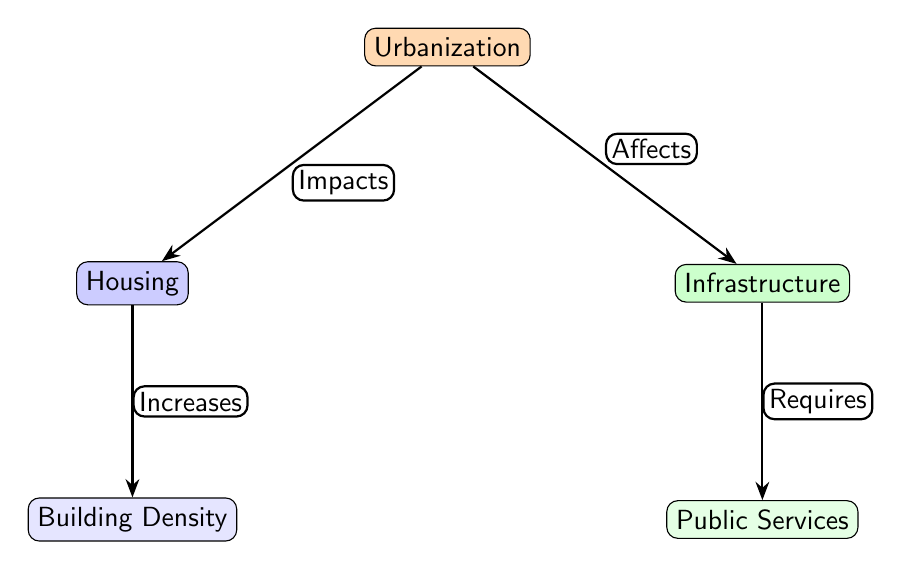What is the central theme of the diagram? The central theme of the diagram is "Urbanization." It is located at the top center of the diagram, indicating that it is the primary concept around which the other elements are organized.
Answer: Urbanization How many nodes are presented in the diagram? The diagram includes five nodes: one for Urbanization, one for Housing, one for Infrastructure, one for Building Density, and one for Public Services. Counting each distinct box gives a total of five nodes.
Answer: Five nodes What effect does urbanization have on housing? Urbanization has a direct impact on housing, as indicated by the arrow labeled "Impacts" connecting Urbanization to Housing. This relationship shows that as urbanization occurs, housing is affected.
Answer: Impacts What relationship is established between housing and building density? The diagram illustrates a direct connection from Housing to Building Density with the label "Increases," indicating that an increase in housing directly correlates to an increase in building density.
Answer: Increases What does infrastructure require according to the diagram? According to the diagram, infrastructure requires public services, as indicated by the arrow labeled "Requires" connecting Infrastructure to Public Services. This shows that as infrastructure develops, it necessitates corresponding public services.
Answer: Requires How does urbanization affect infrastructure according to the diagram? The diagram specifies that urbanization affects infrastructure, as shown by the arrow labeled "Affects" that directly connects Urbanization to Infrastructure. This means that urbanization influences or changes the state of infrastructure.
Answer: Affects Which two nodes represent the outcomes of urbanization? The two nodes that represent the outcomes of urbanization in the diagram are Housing and Infrastructure. Both are directly impacted by the central node of Urbanization, illustrating its effects.
Answer: Housing and Infrastructure If housing increases, what happens to building density? If housing increases, building density also increases, as shown by the arrow from Housing to Building Density labeled "Increases," indicating a direct relationship where one influences the other positively.
Answer: Increases What is the purpose of the arrows in the diagram? The arrows in the diagram serve to illustrate the relationships between the nodes, indicating the flow of impact or requirement among the different components related to urbanization.
Answer: Illustrate relationships 